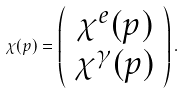<formula> <loc_0><loc_0><loc_500><loc_500>\chi ( p ) = \left ( \begin{array} { c } \chi ^ { e } ( p ) \\ \chi ^ { \gamma } ( p ) \end{array} \right ) .</formula> 